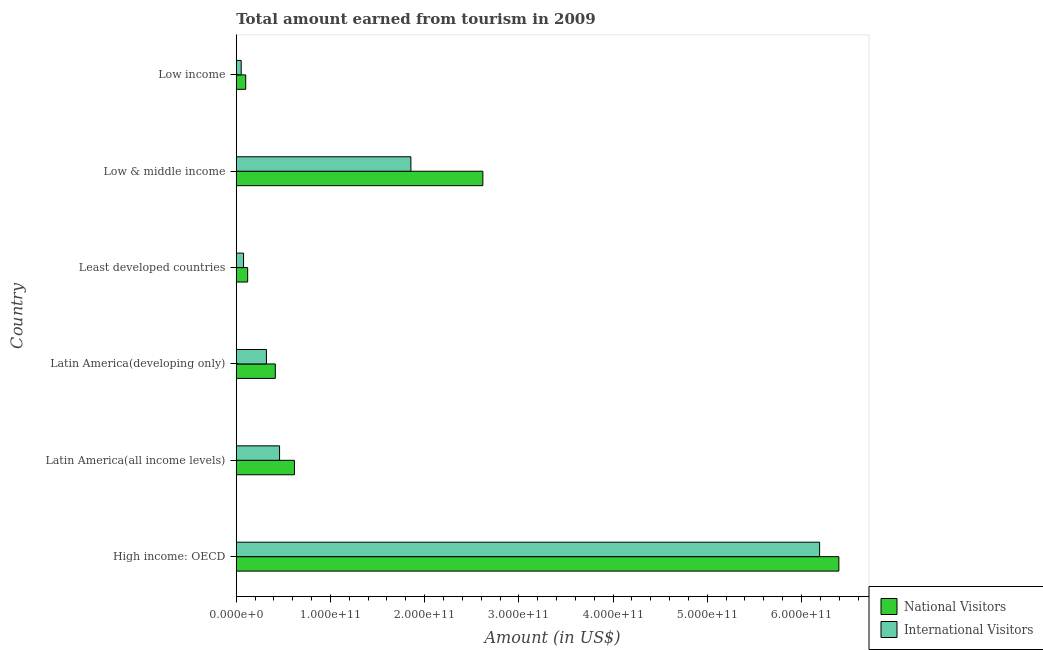Are the number of bars on each tick of the Y-axis equal?
Give a very brief answer. Yes. How many bars are there on the 5th tick from the top?
Offer a very short reply. 2. How many bars are there on the 5th tick from the bottom?
Provide a succinct answer. 2. What is the label of the 5th group of bars from the top?
Offer a terse response. Latin America(all income levels). What is the amount earned from international visitors in Low & middle income?
Offer a terse response. 1.85e+11. Across all countries, what is the maximum amount earned from national visitors?
Offer a very short reply. 6.40e+11. Across all countries, what is the minimum amount earned from international visitors?
Your answer should be very brief. 5.25e+09. In which country was the amount earned from international visitors maximum?
Give a very brief answer. High income: OECD. What is the total amount earned from national visitors in the graph?
Ensure brevity in your answer.  1.03e+12. What is the difference between the amount earned from international visitors in Latin America(developing only) and that in Low & middle income?
Offer a terse response. -1.53e+11. What is the difference between the amount earned from national visitors in Low income and the amount earned from international visitors in Latin America(all income levels)?
Ensure brevity in your answer.  -3.59e+1. What is the average amount earned from international visitors per country?
Keep it short and to the point. 1.49e+11. What is the difference between the amount earned from international visitors and amount earned from national visitors in Latin America(developing only)?
Offer a very short reply. -9.42e+09. What is the ratio of the amount earned from international visitors in Latin America(all income levels) to that in Low income?
Provide a succinct answer. 8.76. Is the difference between the amount earned from national visitors in High income: OECD and Low & middle income greater than the difference between the amount earned from international visitors in High income: OECD and Low & middle income?
Provide a succinct answer. No. What is the difference between the highest and the second highest amount earned from international visitors?
Make the answer very short. 4.34e+11. What is the difference between the highest and the lowest amount earned from international visitors?
Offer a terse response. 6.14e+11. In how many countries, is the amount earned from national visitors greater than the average amount earned from national visitors taken over all countries?
Offer a very short reply. 2. Is the sum of the amount earned from national visitors in Least developed countries and Low & middle income greater than the maximum amount earned from international visitors across all countries?
Provide a short and direct response. No. What does the 1st bar from the top in High income: OECD represents?
Provide a short and direct response. International Visitors. What does the 1st bar from the bottom in Latin America(developing only) represents?
Ensure brevity in your answer.  National Visitors. How many bars are there?
Your response must be concise. 12. Are all the bars in the graph horizontal?
Provide a succinct answer. Yes. What is the difference between two consecutive major ticks on the X-axis?
Provide a succinct answer. 1.00e+11. Does the graph contain grids?
Your answer should be compact. No. How many legend labels are there?
Provide a succinct answer. 2. How are the legend labels stacked?
Offer a terse response. Vertical. What is the title of the graph?
Keep it short and to the point. Total amount earned from tourism in 2009. What is the label or title of the X-axis?
Provide a succinct answer. Amount (in US$). What is the label or title of the Y-axis?
Ensure brevity in your answer.  Country. What is the Amount (in US$) in National Visitors in High income: OECD?
Give a very brief answer. 6.40e+11. What is the Amount (in US$) of International Visitors in High income: OECD?
Your answer should be very brief. 6.19e+11. What is the Amount (in US$) of National Visitors in Latin America(all income levels)?
Make the answer very short. 6.18e+1. What is the Amount (in US$) of International Visitors in Latin America(all income levels)?
Make the answer very short. 4.60e+1. What is the Amount (in US$) of National Visitors in Latin America(developing only)?
Provide a short and direct response. 4.15e+1. What is the Amount (in US$) in International Visitors in Latin America(developing only)?
Make the answer very short. 3.20e+1. What is the Amount (in US$) of National Visitors in Least developed countries?
Offer a very short reply. 1.21e+1. What is the Amount (in US$) of International Visitors in Least developed countries?
Give a very brief answer. 7.76e+09. What is the Amount (in US$) of National Visitors in Low & middle income?
Keep it short and to the point. 2.62e+11. What is the Amount (in US$) of International Visitors in Low & middle income?
Make the answer very short. 1.85e+11. What is the Amount (in US$) in National Visitors in Low income?
Offer a very short reply. 1.01e+1. What is the Amount (in US$) in International Visitors in Low income?
Provide a succinct answer. 5.25e+09. Across all countries, what is the maximum Amount (in US$) in National Visitors?
Your answer should be compact. 6.40e+11. Across all countries, what is the maximum Amount (in US$) of International Visitors?
Keep it short and to the point. 6.19e+11. Across all countries, what is the minimum Amount (in US$) of National Visitors?
Make the answer very short. 1.01e+1. Across all countries, what is the minimum Amount (in US$) in International Visitors?
Keep it short and to the point. 5.25e+09. What is the total Amount (in US$) in National Visitors in the graph?
Provide a succinct answer. 1.03e+12. What is the total Amount (in US$) of International Visitors in the graph?
Your answer should be very brief. 8.96e+11. What is the difference between the Amount (in US$) in National Visitors in High income: OECD and that in Latin America(all income levels)?
Offer a terse response. 5.78e+11. What is the difference between the Amount (in US$) in International Visitors in High income: OECD and that in Latin America(all income levels)?
Give a very brief answer. 5.73e+11. What is the difference between the Amount (in US$) of National Visitors in High income: OECD and that in Latin America(developing only)?
Your answer should be very brief. 5.98e+11. What is the difference between the Amount (in US$) of International Visitors in High income: OECD and that in Latin America(developing only)?
Your response must be concise. 5.87e+11. What is the difference between the Amount (in US$) in National Visitors in High income: OECD and that in Least developed countries?
Give a very brief answer. 6.28e+11. What is the difference between the Amount (in US$) of International Visitors in High income: OECD and that in Least developed countries?
Provide a succinct answer. 6.11e+11. What is the difference between the Amount (in US$) in National Visitors in High income: OECD and that in Low & middle income?
Make the answer very short. 3.78e+11. What is the difference between the Amount (in US$) in International Visitors in High income: OECD and that in Low & middle income?
Your answer should be compact. 4.34e+11. What is the difference between the Amount (in US$) in National Visitors in High income: OECD and that in Low income?
Keep it short and to the point. 6.30e+11. What is the difference between the Amount (in US$) in International Visitors in High income: OECD and that in Low income?
Make the answer very short. 6.14e+11. What is the difference between the Amount (in US$) in National Visitors in Latin America(all income levels) and that in Latin America(developing only)?
Give a very brief answer. 2.03e+1. What is the difference between the Amount (in US$) of International Visitors in Latin America(all income levels) and that in Latin America(developing only)?
Ensure brevity in your answer.  1.39e+1. What is the difference between the Amount (in US$) of National Visitors in Latin America(all income levels) and that in Least developed countries?
Ensure brevity in your answer.  4.97e+1. What is the difference between the Amount (in US$) of International Visitors in Latin America(all income levels) and that in Least developed countries?
Offer a very short reply. 3.82e+1. What is the difference between the Amount (in US$) of National Visitors in Latin America(all income levels) and that in Low & middle income?
Offer a terse response. -2.00e+11. What is the difference between the Amount (in US$) of International Visitors in Latin America(all income levels) and that in Low & middle income?
Offer a very short reply. -1.39e+11. What is the difference between the Amount (in US$) of National Visitors in Latin America(all income levels) and that in Low income?
Ensure brevity in your answer.  5.17e+1. What is the difference between the Amount (in US$) in International Visitors in Latin America(all income levels) and that in Low income?
Ensure brevity in your answer.  4.07e+1. What is the difference between the Amount (in US$) in National Visitors in Latin America(developing only) and that in Least developed countries?
Your response must be concise. 2.94e+1. What is the difference between the Amount (in US$) in International Visitors in Latin America(developing only) and that in Least developed countries?
Offer a very short reply. 2.43e+1. What is the difference between the Amount (in US$) in National Visitors in Latin America(developing only) and that in Low & middle income?
Offer a very short reply. -2.20e+11. What is the difference between the Amount (in US$) in International Visitors in Latin America(developing only) and that in Low & middle income?
Keep it short and to the point. -1.53e+11. What is the difference between the Amount (in US$) of National Visitors in Latin America(developing only) and that in Low income?
Keep it short and to the point. 3.14e+1. What is the difference between the Amount (in US$) in International Visitors in Latin America(developing only) and that in Low income?
Offer a very short reply. 2.68e+1. What is the difference between the Amount (in US$) of National Visitors in Least developed countries and that in Low & middle income?
Provide a succinct answer. -2.50e+11. What is the difference between the Amount (in US$) in International Visitors in Least developed countries and that in Low & middle income?
Your answer should be very brief. -1.78e+11. What is the difference between the Amount (in US$) in National Visitors in Least developed countries and that in Low income?
Provide a succinct answer. 2.06e+09. What is the difference between the Amount (in US$) of International Visitors in Least developed countries and that in Low income?
Ensure brevity in your answer.  2.51e+09. What is the difference between the Amount (in US$) of National Visitors in Low & middle income and that in Low income?
Offer a very short reply. 2.52e+11. What is the difference between the Amount (in US$) in International Visitors in Low & middle income and that in Low income?
Make the answer very short. 1.80e+11. What is the difference between the Amount (in US$) in National Visitors in High income: OECD and the Amount (in US$) in International Visitors in Latin America(all income levels)?
Offer a terse response. 5.94e+11. What is the difference between the Amount (in US$) of National Visitors in High income: OECD and the Amount (in US$) of International Visitors in Latin America(developing only)?
Ensure brevity in your answer.  6.08e+11. What is the difference between the Amount (in US$) in National Visitors in High income: OECD and the Amount (in US$) in International Visitors in Least developed countries?
Give a very brief answer. 6.32e+11. What is the difference between the Amount (in US$) in National Visitors in High income: OECD and the Amount (in US$) in International Visitors in Low & middle income?
Your answer should be compact. 4.54e+11. What is the difference between the Amount (in US$) of National Visitors in High income: OECD and the Amount (in US$) of International Visitors in Low income?
Provide a short and direct response. 6.34e+11. What is the difference between the Amount (in US$) of National Visitors in Latin America(all income levels) and the Amount (in US$) of International Visitors in Latin America(developing only)?
Provide a succinct answer. 2.97e+1. What is the difference between the Amount (in US$) in National Visitors in Latin America(all income levels) and the Amount (in US$) in International Visitors in Least developed countries?
Offer a very short reply. 5.40e+1. What is the difference between the Amount (in US$) in National Visitors in Latin America(all income levels) and the Amount (in US$) in International Visitors in Low & middle income?
Your answer should be compact. -1.24e+11. What is the difference between the Amount (in US$) of National Visitors in Latin America(all income levels) and the Amount (in US$) of International Visitors in Low income?
Offer a very short reply. 5.65e+1. What is the difference between the Amount (in US$) of National Visitors in Latin America(developing only) and the Amount (in US$) of International Visitors in Least developed countries?
Offer a very short reply. 3.37e+1. What is the difference between the Amount (in US$) of National Visitors in Latin America(developing only) and the Amount (in US$) of International Visitors in Low & middle income?
Provide a short and direct response. -1.44e+11. What is the difference between the Amount (in US$) in National Visitors in Latin America(developing only) and the Amount (in US$) in International Visitors in Low income?
Your answer should be very brief. 3.62e+1. What is the difference between the Amount (in US$) of National Visitors in Least developed countries and the Amount (in US$) of International Visitors in Low & middle income?
Make the answer very short. -1.73e+11. What is the difference between the Amount (in US$) in National Visitors in Least developed countries and the Amount (in US$) in International Visitors in Low income?
Offer a very short reply. 6.86e+09. What is the difference between the Amount (in US$) of National Visitors in Low & middle income and the Amount (in US$) of International Visitors in Low income?
Offer a very short reply. 2.57e+11. What is the average Amount (in US$) of National Visitors per country?
Your answer should be very brief. 1.71e+11. What is the average Amount (in US$) in International Visitors per country?
Your response must be concise. 1.49e+11. What is the difference between the Amount (in US$) in National Visitors and Amount (in US$) in International Visitors in High income: OECD?
Offer a terse response. 2.04e+1. What is the difference between the Amount (in US$) in National Visitors and Amount (in US$) in International Visitors in Latin America(all income levels)?
Provide a short and direct response. 1.58e+1. What is the difference between the Amount (in US$) of National Visitors and Amount (in US$) of International Visitors in Latin America(developing only)?
Your answer should be compact. 9.42e+09. What is the difference between the Amount (in US$) of National Visitors and Amount (in US$) of International Visitors in Least developed countries?
Give a very brief answer. 4.35e+09. What is the difference between the Amount (in US$) of National Visitors and Amount (in US$) of International Visitors in Low & middle income?
Your answer should be compact. 7.64e+1. What is the difference between the Amount (in US$) in National Visitors and Amount (in US$) in International Visitors in Low income?
Offer a very short reply. 4.80e+09. What is the ratio of the Amount (in US$) of National Visitors in High income: OECD to that in Latin America(all income levels)?
Your answer should be compact. 10.35. What is the ratio of the Amount (in US$) in International Visitors in High income: OECD to that in Latin America(all income levels)?
Provide a succinct answer. 13.47. What is the ratio of the Amount (in US$) of National Visitors in High income: OECD to that in Latin America(developing only)?
Give a very brief answer. 15.43. What is the ratio of the Amount (in US$) of International Visitors in High income: OECD to that in Latin America(developing only)?
Offer a terse response. 19.33. What is the ratio of the Amount (in US$) of National Visitors in High income: OECD to that in Least developed countries?
Give a very brief answer. 52.83. What is the ratio of the Amount (in US$) in International Visitors in High income: OECD to that in Least developed countries?
Give a very brief answer. 79.8. What is the ratio of the Amount (in US$) of National Visitors in High income: OECD to that in Low & middle income?
Ensure brevity in your answer.  2.44. What is the ratio of the Amount (in US$) in International Visitors in High income: OECD to that in Low & middle income?
Make the answer very short. 3.34. What is the ratio of the Amount (in US$) in National Visitors in High income: OECD to that in Low income?
Give a very brief answer. 63.65. What is the ratio of the Amount (in US$) in International Visitors in High income: OECD to that in Low income?
Keep it short and to the point. 118.02. What is the ratio of the Amount (in US$) of National Visitors in Latin America(all income levels) to that in Latin America(developing only)?
Provide a succinct answer. 1.49. What is the ratio of the Amount (in US$) of International Visitors in Latin America(all income levels) to that in Latin America(developing only)?
Your response must be concise. 1.44. What is the ratio of the Amount (in US$) in National Visitors in Latin America(all income levels) to that in Least developed countries?
Make the answer very short. 5.1. What is the ratio of the Amount (in US$) of International Visitors in Latin America(all income levels) to that in Least developed countries?
Your answer should be compact. 5.93. What is the ratio of the Amount (in US$) in National Visitors in Latin America(all income levels) to that in Low & middle income?
Make the answer very short. 0.24. What is the ratio of the Amount (in US$) of International Visitors in Latin America(all income levels) to that in Low & middle income?
Your answer should be compact. 0.25. What is the ratio of the Amount (in US$) of National Visitors in Latin America(all income levels) to that in Low income?
Your answer should be compact. 6.15. What is the ratio of the Amount (in US$) in International Visitors in Latin America(all income levels) to that in Low income?
Make the answer very short. 8.76. What is the ratio of the Amount (in US$) of National Visitors in Latin America(developing only) to that in Least developed countries?
Your answer should be very brief. 3.42. What is the ratio of the Amount (in US$) of International Visitors in Latin America(developing only) to that in Least developed countries?
Your answer should be compact. 4.13. What is the ratio of the Amount (in US$) in National Visitors in Latin America(developing only) to that in Low & middle income?
Make the answer very short. 0.16. What is the ratio of the Amount (in US$) of International Visitors in Latin America(developing only) to that in Low & middle income?
Your answer should be compact. 0.17. What is the ratio of the Amount (in US$) of National Visitors in Latin America(developing only) to that in Low income?
Make the answer very short. 4.13. What is the ratio of the Amount (in US$) of International Visitors in Latin America(developing only) to that in Low income?
Your response must be concise. 6.11. What is the ratio of the Amount (in US$) of National Visitors in Least developed countries to that in Low & middle income?
Your answer should be very brief. 0.05. What is the ratio of the Amount (in US$) of International Visitors in Least developed countries to that in Low & middle income?
Ensure brevity in your answer.  0.04. What is the ratio of the Amount (in US$) in National Visitors in Least developed countries to that in Low income?
Provide a short and direct response. 1.2. What is the ratio of the Amount (in US$) in International Visitors in Least developed countries to that in Low income?
Give a very brief answer. 1.48. What is the ratio of the Amount (in US$) in National Visitors in Low & middle income to that in Low income?
Provide a short and direct response. 26.04. What is the ratio of the Amount (in US$) in International Visitors in Low & middle income to that in Low income?
Offer a very short reply. 35.33. What is the difference between the highest and the second highest Amount (in US$) in National Visitors?
Give a very brief answer. 3.78e+11. What is the difference between the highest and the second highest Amount (in US$) of International Visitors?
Offer a very short reply. 4.34e+11. What is the difference between the highest and the lowest Amount (in US$) in National Visitors?
Give a very brief answer. 6.30e+11. What is the difference between the highest and the lowest Amount (in US$) of International Visitors?
Ensure brevity in your answer.  6.14e+11. 